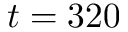Convert formula to latex. <formula><loc_0><loc_0><loc_500><loc_500>t = 3 2 0</formula> 